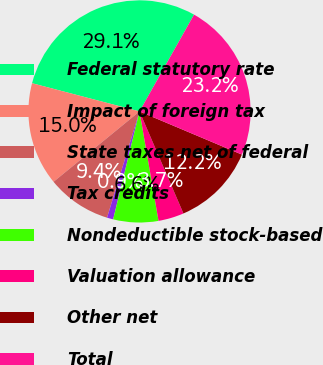Convert chart to OTSL. <chart><loc_0><loc_0><loc_500><loc_500><pie_chart><fcel>Federal statutory rate<fcel>Impact of foreign tax<fcel>State taxes net of federal<fcel>Tax credits<fcel>Nondeductible stock-based<fcel>Valuation allowance<fcel>Other net<fcel>Total<nl><fcel>29.08%<fcel>15.0%<fcel>9.36%<fcel>0.91%<fcel>6.55%<fcel>3.73%<fcel>12.18%<fcel>23.18%<nl></chart> 